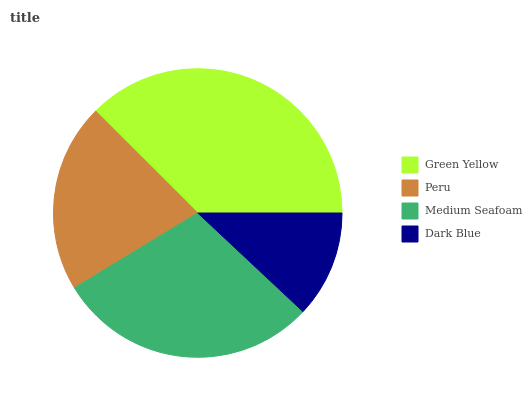Is Dark Blue the minimum?
Answer yes or no. Yes. Is Green Yellow the maximum?
Answer yes or no. Yes. Is Peru the minimum?
Answer yes or no. No. Is Peru the maximum?
Answer yes or no. No. Is Green Yellow greater than Peru?
Answer yes or no. Yes. Is Peru less than Green Yellow?
Answer yes or no. Yes. Is Peru greater than Green Yellow?
Answer yes or no. No. Is Green Yellow less than Peru?
Answer yes or no. No. Is Medium Seafoam the high median?
Answer yes or no. Yes. Is Peru the low median?
Answer yes or no. Yes. Is Green Yellow the high median?
Answer yes or no. No. Is Medium Seafoam the low median?
Answer yes or no. No. 